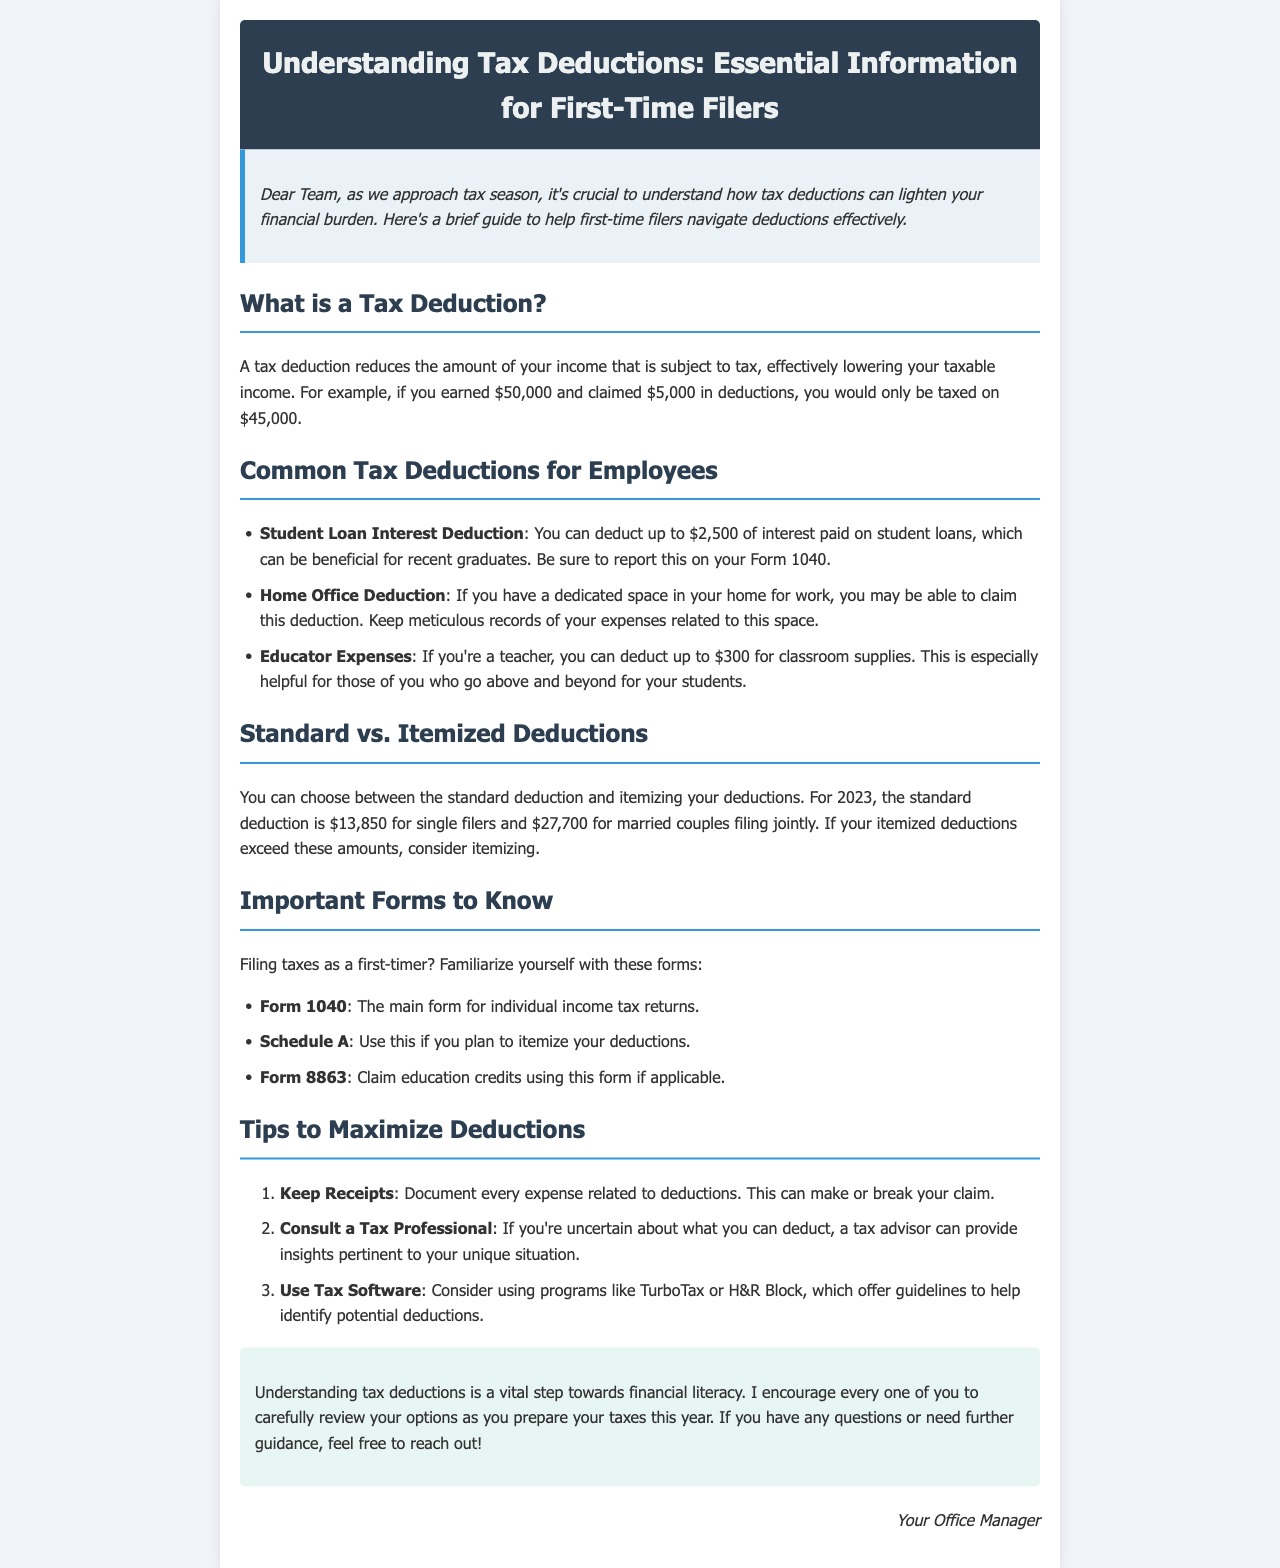What is a tax deduction? A tax deduction reduces the amount of your income that is subject to tax, effectively lowering your taxable income.
Answer: A tax deduction reduces taxable income What is the standard deduction for single filers in 2023? The standard deduction for single filers is specified in the document.
Answer: $13,850 How much can teachers deduct for classroom supplies? This amount is mentioned specifically in the context of educator expenses.
Answer: Up to $300 Which form is for individual income tax returns? The document lists important forms one should know, identifying the main form for individual income tax returns.
Answer: Form 1040 What should you do if you're uncertain about what you can deduct? The document provides a suggestion for those uncertain about deductions.
Answer: Consult a tax professional What is the maximum amount for student loan interest deduction? The text indicates the maximum deductible amount for student loan interest explicitly.
Answer: $2,500 Which section discusses tips to maximize deductions? This aspect of the document is clearly labeled, guiding readers to the related content.
Answer: Tips to Maximize Deductions What is the recommended action for documentation related to deductions? This is highlighted in the tips section, emphasizing the importance of proper record-keeping.
Answer: Keep receipts How can tax software assist you? The document addresses this question in the tips section, suggesting a specific benefit.
Answer: Identify potential deductions 